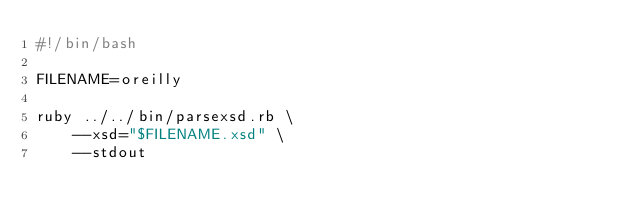<code> <loc_0><loc_0><loc_500><loc_500><_Bash_>#!/bin/bash

FILENAME=oreilly

ruby ../../bin/parsexsd.rb \
    --xsd="$FILENAME.xsd" \
    --stdout
</code> 